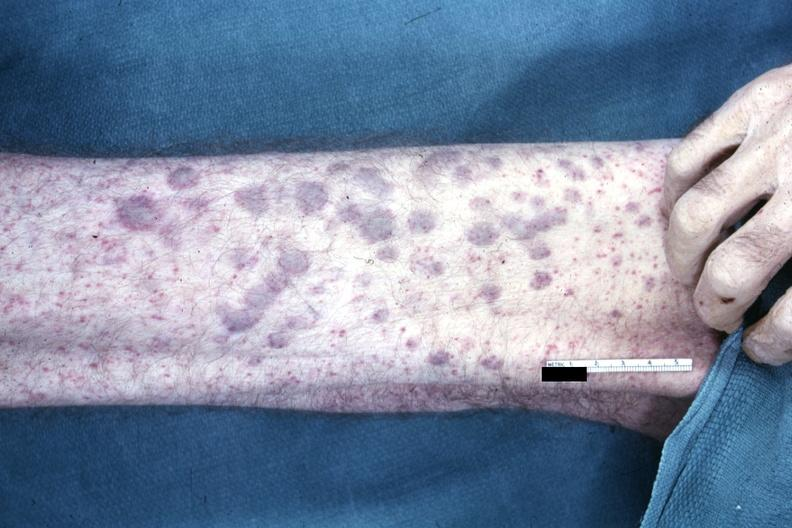what is present?
Answer the question using a single word or phrase. Acute myelogenous leukemia 